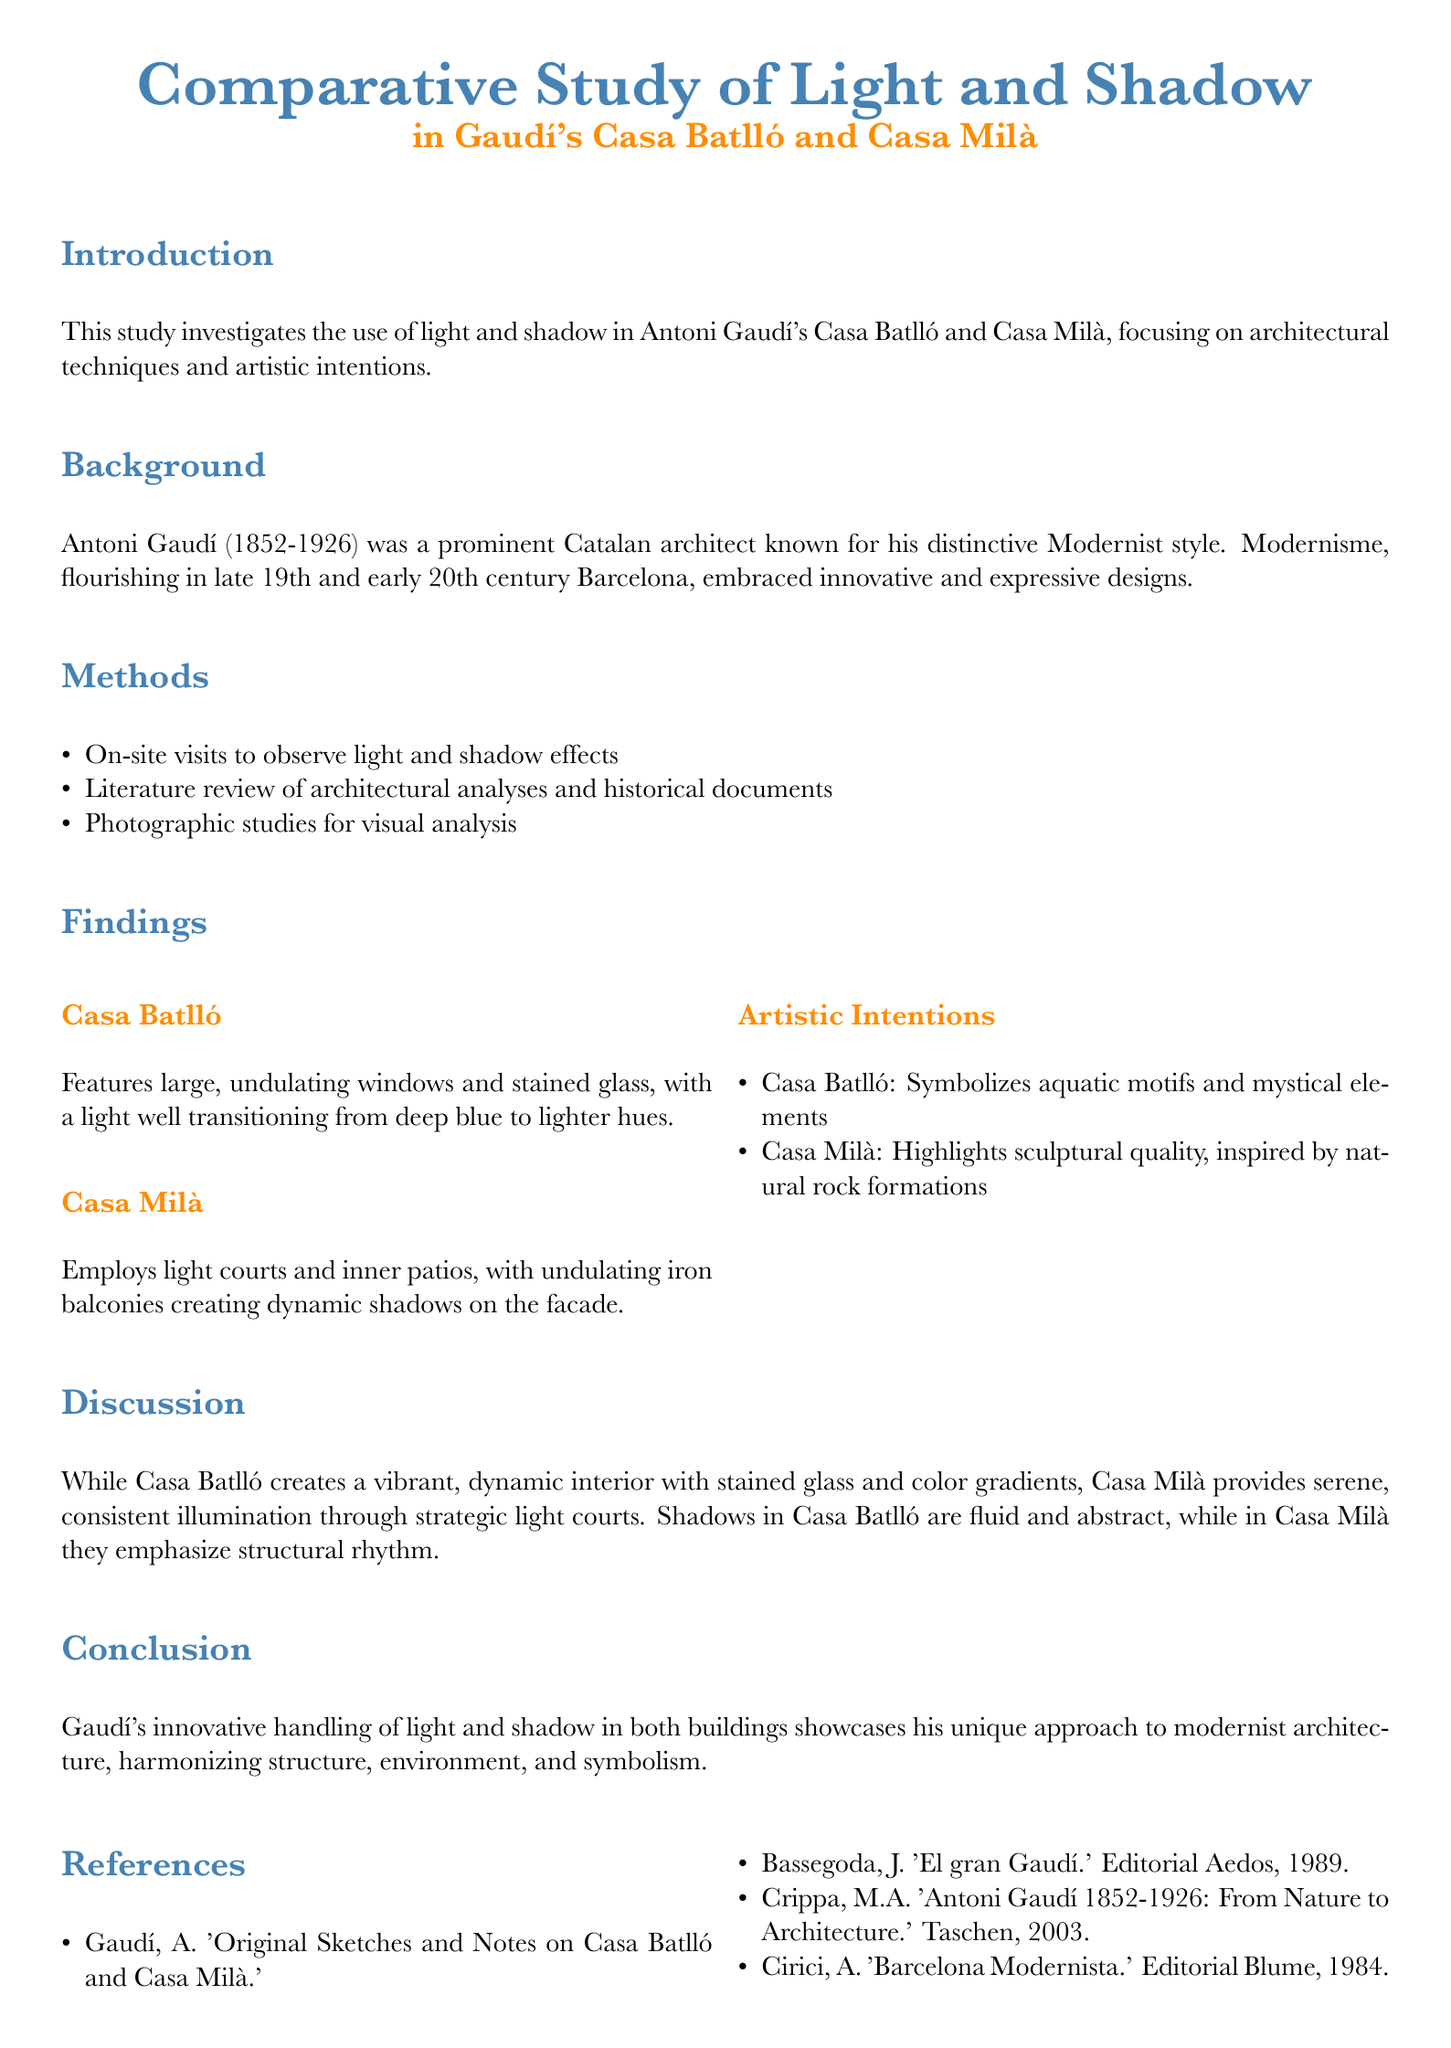What is the main focus of this study? The study focuses on the use of light and shadow in Casa Batlló and Casa Milà, analyzing architectural techniques and artistic intentions.
Answer: Light and shadow Who are the two main architects discussed in the document? The document prominently discusses Antoni Gaudí and the Modernist architectural movement.
Answer: Antoni Gaudí What architectural feature is highlighted in Casa Batlló? Casa Batlló features large, undulating windows and stained glass, which contribute to its light effects.
Answer: Large, undulating windows What artistic motif does Casa Batlló symbolize? Casa Batlló symbolizes aquatic motifs and mystical elements.
Answer: Aquatic motifs Which building provides serene, consistent illumination? The document mentions that Casa Milà offers serene, consistent illumination through its architectural features.
Answer: Casa Milà What strategy does Casa Milà employ to create dynamic shadows? Casa Milà utilizes undulating iron balconies to create dynamic shadows across its facade.
Answer: Undulating iron balconies How many references are listed in the document? The references section includes a total of four notable works related to Gaudí and his architecture.
Answer: Four What type of analysis method was used aside from on-site visits? The document states that a literature review was conducted to complement the on-site observations.
Answer: Literature review What year did Antoni Gaudí pass away? The findings include Gaudí's life span, noting his death in the year 1926.
Answer: 1926 